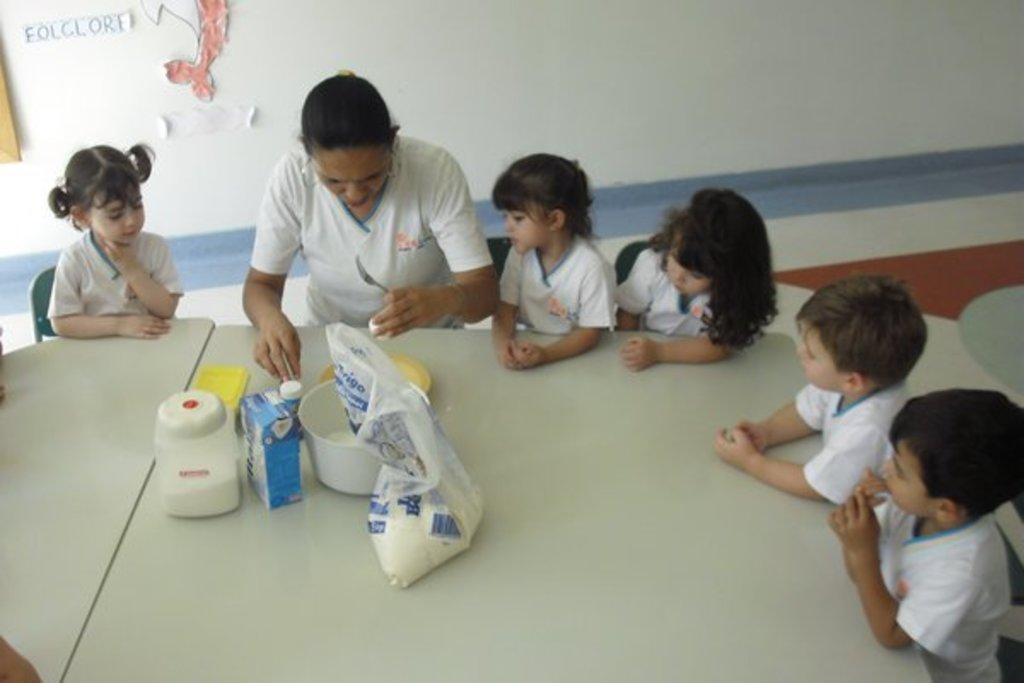Describe this image in one or two sentences. In the image we can see a woman and children's sitting, they are wearing the same costume. Here we can see the table, on the table, we can see the container, plate, plastic bag and other things. We can even see there are chairs and the wall. 